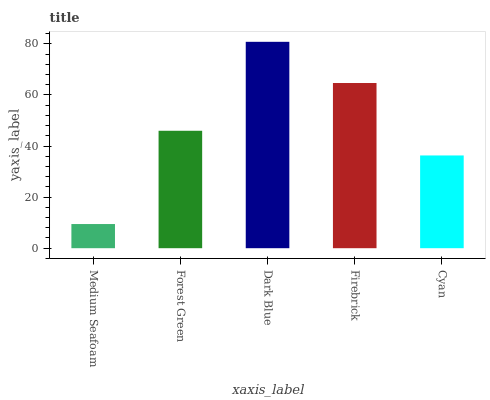Is Medium Seafoam the minimum?
Answer yes or no. Yes. Is Dark Blue the maximum?
Answer yes or no. Yes. Is Forest Green the minimum?
Answer yes or no. No. Is Forest Green the maximum?
Answer yes or no. No. Is Forest Green greater than Medium Seafoam?
Answer yes or no. Yes. Is Medium Seafoam less than Forest Green?
Answer yes or no. Yes. Is Medium Seafoam greater than Forest Green?
Answer yes or no. No. Is Forest Green less than Medium Seafoam?
Answer yes or no. No. Is Forest Green the high median?
Answer yes or no. Yes. Is Forest Green the low median?
Answer yes or no. Yes. Is Medium Seafoam the high median?
Answer yes or no. No. Is Dark Blue the low median?
Answer yes or no. No. 